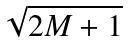<formula> <loc_0><loc_0><loc_500><loc_500>\sqrt { 2 M + 1 }</formula> 